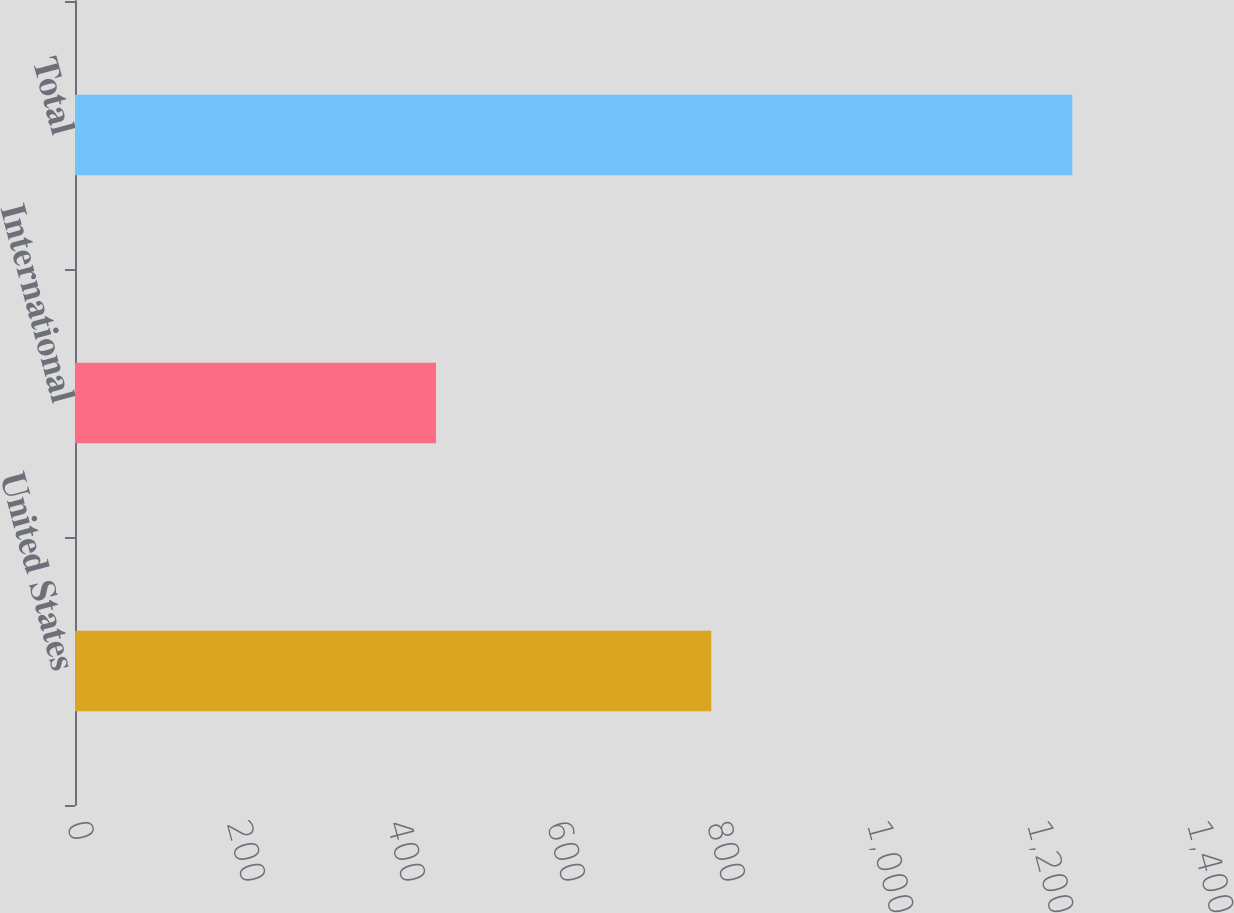Convert chart to OTSL. <chart><loc_0><loc_0><loc_500><loc_500><bar_chart><fcel>United States<fcel>International<fcel>Total<nl><fcel>795.3<fcel>451.3<fcel>1246.6<nl></chart> 